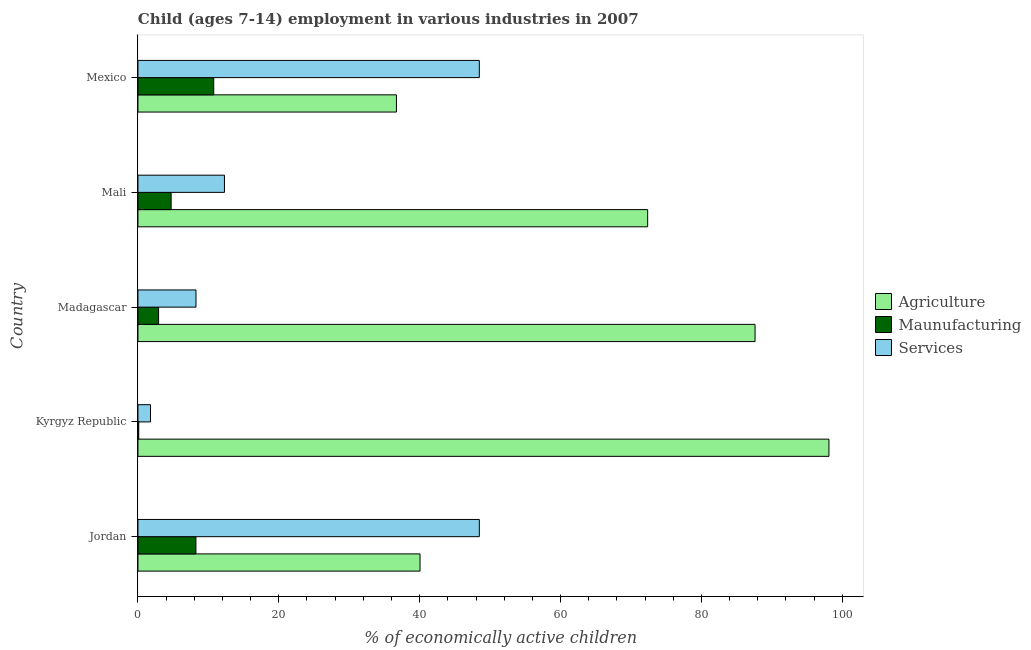How many groups of bars are there?
Your answer should be very brief. 5. Are the number of bars on each tick of the Y-axis equal?
Give a very brief answer. Yes. How many bars are there on the 2nd tick from the top?
Provide a succinct answer. 3. What is the label of the 3rd group of bars from the top?
Offer a very short reply. Madagascar. In how many cases, is the number of bars for a given country not equal to the number of legend labels?
Offer a terse response. 0. What is the percentage of economically active children in manufacturing in Mexico?
Provide a short and direct response. 10.76. Across all countries, what is the maximum percentage of economically active children in agriculture?
Your response must be concise. 98.11. Across all countries, what is the minimum percentage of economically active children in manufacturing?
Give a very brief answer. 0.11. In which country was the percentage of economically active children in manufacturing maximum?
Provide a succinct answer. Mexico. In which country was the percentage of economically active children in services minimum?
Your answer should be compact. Kyrgyz Republic. What is the total percentage of economically active children in manufacturing in the graph?
Give a very brief answer. 26.74. What is the difference between the percentage of economically active children in services in Mali and that in Mexico?
Ensure brevity in your answer.  -36.19. What is the difference between the percentage of economically active children in manufacturing in Mali and the percentage of economically active children in agriculture in Jordan?
Ensure brevity in your answer.  -35.34. What is the average percentage of economically active children in agriculture per country?
Offer a terse response. 66.97. What is the difference between the percentage of economically active children in services and percentage of economically active children in manufacturing in Madagascar?
Give a very brief answer. 5.31. What is the ratio of the percentage of economically active children in services in Madagascar to that in Mali?
Provide a succinct answer. 0.67. Is the difference between the percentage of economically active children in services in Kyrgyz Republic and Mali greater than the difference between the percentage of economically active children in manufacturing in Kyrgyz Republic and Mali?
Your response must be concise. No. What is the difference between the highest and the second highest percentage of economically active children in services?
Your response must be concise. 0. What is the difference between the highest and the lowest percentage of economically active children in services?
Your response must be concise. 46.69. Is the sum of the percentage of economically active children in services in Madagascar and Mali greater than the maximum percentage of economically active children in agriculture across all countries?
Keep it short and to the point. No. What does the 2nd bar from the top in Madagascar represents?
Make the answer very short. Maunufacturing. What does the 3rd bar from the bottom in Jordan represents?
Your response must be concise. Services. How many bars are there?
Offer a terse response. 15. Are all the bars in the graph horizontal?
Make the answer very short. Yes. How many countries are there in the graph?
Provide a short and direct response. 5. Does the graph contain any zero values?
Your answer should be very brief. No. Does the graph contain grids?
Ensure brevity in your answer.  No. What is the title of the graph?
Your answer should be compact. Child (ages 7-14) employment in various industries in 2007. Does "Total employers" appear as one of the legend labels in the graph?
Give a very brief answer. No. What is the label or title of the X-axis?
Offer a terse response. % of economically active children. What is the % of economically active children in Agriculture in Jordan?
Your answer should be compact. 40.05. What is the % of economically active children in Maunufacturing in Jordan?
Ensure brevity in your answer.  8.23. What is the % of economically active children of Services in Jordan?
Offer a terse response. 48.47. What is the % of economically active children of Agriculture in Kyrgyz Republic?
Make the answer very short. 98.11. What is the % of economically active children in Maunufacturing in Kyrgyz Republic?
Offer a very short reply. 0.11. What is the % of economically active children in Services in Kyrgyz Republic?
Provide a succinct answer. 1.78. What is the % of economically active children in Agriculture in Madagascar?
Give a very brief answer. 87.62. What is the % of economically active children of Maunufacturing in Madagascar?
Offer a very short reply. 2.93. What is the % of economically active children in Services in Madagascar?
Ensure brevity in your answer.  8.24. What is the % of economically active children of Agriculture in Mali?
Keep it short and to the point. 72.37. What is the % of economically active children of Maunufacturing in Mali?
Offer a terse response. 4.71. What is the % of economically active children in Services in Mali?
Your answer should be compact. 12.28. What is the % of economically active children of Agriculture in Mexico?
Your answer should be compact. 36.7. What is the % of economically active children in Maunufacturing in Mexico?
Make the answer very short. 10.76. What is the % of economically active children of Services in Mexico?
Your response must be concise. 48.47. Across all countries, what is the maximum % of economically active children of Agriculture?
Your answer should be very brief. 98.11. Across all countries, what is the maximum % of economically active children in Maunufacturing?
Make the answer very short. 10.76. Across all countries, what is the maximum % of economically active children of Services?
Give a very brief answer. 48.47. Across all countries, what is the minimum % of economically active children in Agriculture?
Make the answer very short. 36.7. Across all countries, what is the minimum % of economically active children in Maunufacturing?
Keep it short and to the point. 0.11. Across all countries, what is the minimum % of economically active children in Services?
Offer a very short reply. 1.78. What is the total % of economically active children in Agriculture in the graph?
Keep it short and to the point. 334.85. What is the total % of economically active children in Maunufacturing in the graph?
Provide a succinct answer. 26.74. What is the total % of economically active children of Services in the graph?
Your response must be concise. 119.24. What is the difference between the % of economically active children of Agriculture in Jordan and that in Kyrgyz Republic?
Provide a succinct answer. -58.06. What is the difference between the % of economically active children of Maunufacturing in Jordan and that in Kyrgyz Republic?
Your answer should be very brief. 8.12. What is the difference between the % of economically active children of Services in Jordan and that in Kyrgyz Republic?
Make the answer very short. 46.69. What is the difference between the % of economically active children of Agriculture in Jordan and that in Madagascar?
Your answer should be compact. -47.57. What is the difference between the % of economically active children of Services in Jordan and that in Madagascar?
Your answer should be compact. 40.23. What is the difference between the % of economically active children in Agriculture in Jordan and that in Mali?
Ensure brevity in your answer.  -32.32. What is the difference between the % of economically active children of Maunufacturing in Jordan and that in Mali?
Make the answer very short. 3.52. What is the difference between the % of economically active children of Services in Jordan and that in Mali?
Provide a succinct answer. 36.19. What is the difference between the % of economically active children of Agriculture in Jordan and that in Mexico?
Offer a very short reply. 3.35. What is the difference between the % of economically active children of Maunufacturing in Jordan and that in Mexico?
Offer a terse response. -2.53. What is the difference between the % of economically active children in Services in Jordan and that in Mexico?
Your response must be concise. 0. What is the difference between the % of economically active children of Agriculture in Kyrgyz Republic and that in Madagascar?
Ensure brevity in your answer.  10.49. What is the difference between the % of economically active children of Maunufacturing in Kyrgyz Republic and that in Madagascar?
Ensure brevity in your answer.  -2.82. What is the difference between the % of economically active children of Services in Kyrgyz Republic and that in Madagascar?
Your answer should be compact. -6.46. What is the difference between the % of economically active children in Agriculture in Kyrgyz Republic and that in Mali?
Offer a very short reply. 25.74. What is the difference between the % of economically active children in Maunufacturing in Kyrgyz Republic and that in Mali?
Keep it short and to the point. -4.6. What is the difference between the % of economically active children in Agriculture in Kyrgyz Republic and that in Mexico?
Keep it short and to the point. 61.41. What is the difference between the % of economically active children of Maunufacturing in Kyrgyz Republic and that in Mexico?
Your answer should be compact. -10.65. What is the difference between the % of economically active children of Services in Kyrgyz Republic and that in Mexico?
Provide a short and direct response. -46.69. What is the difference between the % of economically active children of Agriculture in Madagascar and that in Mali?
Keep it short and to the point. 15.25. What is the difference between the % of economically active children in Maunufacturing in Madagascar and that in Mali?
Offer a terse response. -1.78. What is the difference between the % of economically active children in Services in Madagascar and that in Mali?
Provide a succinct answer. -4.04. What is the difference between the % of economically active children in Agriculture in Madagascar and that in Mexico?
Provide a short and direct response. 50.92. What is the difference between the % of economically active children in Maunufacturing in Madagascar and that in Mexico?
Make the answer very short. -7.83. What is the difference between the % of economically active children in Services in Madagascar and that in Mexico?
Keep it short and to the point. -40.23. What is the difference between the % of economically active children in Agriculture in Mali and that in Mexico?
Ensure brevity in your answer.  35.67. What is the difference between the % of economically active children in Maunufacturing in Mali and that in Mexico?
Provide a short and direct response. -6.05. What is the difference between the % of economically active children of Services in Mali and that in Mexico?
Your answer should be very brief. -36.19. What is the difference between the % of economically active children of Agriculture in Jordan and the % of economically active children of Maunufacturing in Kyrgyz Republic?
Your response must be concise. 39.94. What is the difference between the % of economically active children in Agriculture in Jordan and the % of economically active children in Services in Kyrgyz Republic?
Keep it short and to the point. 38.27. What is the difference between the % of economically active children of Maunufacturing in Jordan and the % of economically active children of Services in Kyrgyz Republic?
Give a very brief answer. 6.45. What is the difference between the % of economically active children in Agriculture in Jordan and the % of economically active children in Maunufacturing in Madagascar?
Your response must be concise. 37.12. What is the difference between the % of economically active children of Agriculture in Jordan and the % of economically active children of Services in Madagascar?
Make the answer very short. 31.81. What is the difference between the % of economically active children in Maunufacturing in Jordan and the % of economically active children in Services in Madagascar?
Your answer should be compact. -0.01. What is the difference between the % of economically active children of Agriculture in Jordan and the % of economically active children of Maunufacturing in Mali?
Provide a succinct answer. 35.34. What is the difference between the % of economically active children of Agriculture in Jordan and the % of economically active children of Services in Mali?
Provide a short and direct response. 27.77. What is the difference between the % of economically active children of Maunufacturing in Jordan and the % of economically active children of Services in Mali?
Offer a very short reply. -4.05. What is the difference between the % of economically active children in Agriculture in Jordan and the % of economically active children in Maunufacturing in Mexico?
Your answer should be compact. 29.29. What is the difference between the % of economically active children of Agriculture in Jordan and the % of economically active children of Services in Mexico?
Provide a succinct answer. -8.42. What is the difference between the % of economically active children of Maunufacturing in Jordan and the % of economically active children of Services in Mexico?
Make the answer very short. -40.24. What is the difference between the % of economically active children of Agriculture in Kyrgyz Republic and the % of economically active children of Maunufacturing in Madagascar?
Offer a terse response. 95.18. What is the difference between the % of economically active children of Agriculture in Kyrgyz Republic and the % of economically active children of Services in Madagascar?
Offer a terse response. 89.87. What is the difference between the % of economically active children in Maunufacturing in Kyrgyz Republic and the % of economically active children in Services in Madagascar?
Offer a terse response. -8.13. What is the difference between the % of economically active children of Agriculture in Kyrgyz Republic and the % of economically active children of Maunufacturing in Mali?
Offer a very short reply. 93.4. What is the difference between the % of economically active children in Agriculture in Kyrgyz Republic and the % of economically active children in Services in Mali?
Offer a terse response. 85.83. What is the difference between the % of economically active children of Maunufacturing in Kyrgyz Republic and the % of economically active children of Services in Mali?
Ensure brevity in your answer.  -12.17. What is the difference between the % of economically active children in Agriculture in Kyrgyz Republic and the % of economically active children in Maunufacturing in Mexico?
Keep it short and to the point. 87.35. What is the difference between the % of economically active children of Agriculture in Kyrgyz Republic and the % of economically active children of Services in Mexico?
Keep it short and to the point. 49.64. What is the difference between the % of economically active children of Maunufacturing in Kyrgyz Republic and the % of economically active children of Services in Mexico?
Make the answer very short. -48.36. What is the difference between the % of economically active children of Agriculture in Madagascar and the % of economically active children of Maunufacturing in Mali?
Keep it short and to the point. 82.91. What is the difference between the % of economically active children in Agriculture in Madagascar and the % of economically active children in Services in Mali?
Make the answer very short. 75.34. What is the difference between the % of economically active children in Maunufacturing in Madagascar and the % of economically active children in Services in Mali?
Keep it short and to the point. -9.35. What is the difference between the % of economically active children in Agriculture in Madagascar and the % of economically active children in Maunufacturing in Mexico?
Your answer should be very brief. 76.86. What is the difference between the % of economically active children in Agriculture in Madagascar and the % of economically active children in Services in Mexico?
Provide a succinct answer. 39.15. What is the difference between the % of economically active children of Maunufacturing in Madagascar and the % of economically active children of Services in Mexico?
Your answer should be very brief. -45.54. What is the difference between the % of economically active children of Agriculture in Mali and the % of economically active children of Maunufacturing in Mexico?
Provide a succinct answer. 61.61. What is the difference between the % of economically active children of Agriculture in Mali and the % of economically active children of Services in Mexico?
Keep it short and to the point. 23.9. What is the difference between the % of economically active children in Maunufacturing in Mali and the % of economically active children in Services in Mexico?
Your response must be concise. -43.76. What is the average % of economically active children in Agriculture per country?
Ensure brevity in your answer.  66.97. What is the average % of economically active children of Maunufacturing per country?
Your response must be concise. 5.35. What is the average % of economically active children of Services per country?
Ensure brevity in your answer.  23.85. What is the difference between the % of economically active children of Agriculture and % of economically active children of Maunufacturing in Jordan?
Make the answer very short. 31.82. What is the difference between the % of economically active children in Agriculture and % of economically active children in Services in Jordan?
Offer a very short reply. -8.42. What is the difference between the % of economically active children in Maunufacturing and % of economically active children in Services in Jordan?
Your answer should be very brief. -40.24. What is the difference between the % of economically active children of Agriculture and % of economically active children of Services in Kyrgyz Republic?
Provide a short and direct response. 96.33. What is the difference between the % of economically active children of Maunufacturing and % of economically active children of Services in Kyrgyz Republic?
Keep it short and to the point. -1.67. What is the difference between the % of economically active children in Agriculture and % of economically active children in Maunufacturing in Madagascar?
Your answer should be very brief. 84.69. What is the difference between the % of economically active children of Agriculture and % of economically active children of Services in Madagascar?
Keep it short and to the point. 79.38. What is the difference between the % of economically active children in Maunufacturing and % of economically active children in Services in Madagascar?
Your response must be concise. -5.31. What is the difference between the % of economically active children of Agriculture and % of economically active children of Maunufacturing in Mali?
Offer a very short reply. 67.66. What is the difference between the % of economically active children in Agriculture and % of economically active children in Services in Mali?
Your answer should be very brief. 60.09. What is the difference between the % of economically active children of Maunufacturing and % of economically active children of Services in Mali?
Your answer should be very brief. -7.57. What is the difference between the % of economically active children in Agriculture and % of economically active children in Maunufacturing in Mexico?
Ensure brevity in your answer.  25.94. What is the difference between the % of economically active children in Agriculture and % of economically active children in Services in Mexico?
Provide a short and direct response. -11.77. What is the difference between the % of economically active children of Maunufacturing and % of economically active children of Services in Mexico?
Provide a short and direct response. -37.71. What is the ratio of the % of economically active children in Agriculture in Jordan to that in Kyrgyz Republic?
Your response must be concise. 0.41. What is the ratio of the % of economically active children in Maunufacturing in Jordan to that in Kyrgyz Republic?
Keep it short and to the point. 74.82. What is the ratio of the % of economically active children of Services in Jordan to that in Kyrgyz Republic?
Provide a succinct answer. 27.23. What is the ratio of the % of economically active children in Agriculture in Jordan to that in Madagascar?
Give a very brief answer. 0.46. What is the ratio of the % of economically active children in Maunufacturing in Jordan to that in Madagascar?
Offer a very short reply. 2.81. What is the ratio of the % of economically active children of Services in Jordan to that in Madagascar?
Offer a very short reply. 5.88. What is the ratio of the % of economically active children of Agriculture in Jordan to that in Mali?
Provide a succinct answer. 0.55. What is the ratio of the % of economically active children of Maunufacturing in Jordan to that in Mali?
Give a very brief answer. 1.75. What is the ratio of the % of economically active children of Services in Jordan to that in Mali?
Provide a short and direct response. 3.95. What is the ratio of the % of economically active children of Agriculture in Jordan to that in Mexico?
Provide a succinct answer. 1.09. What is the ratio of the % of economically active children of Maunufacturing in Jordan to that in Mexico?
Your answer should be very brief. 0.76. What is the ratio of the % of economically active children of Services in Jordan to that in Mexico?
Offer a terse response. 1. What is the ratio of the % of economically active children of Agriculture in Kyrgyz Republic to that in Madagascar?
Keep it short and to the point. 1.12. What is the ratio of the % of economically active children of Maunufacturing in Kyrgyz Republic to that in Madagascar?
Offer a terse response. 0.04. What is the ratio of the % of economically active children in Services in Kyrgyz Republic to that in Madagascar?
Provide a short and direct response. 0.22. What is the ratio of the % of economically active children of Agriculture in Kyrgyz Republic to that in Mali?
Your response must be concise. 1.36. What is the ratio of the % of economically active children in Maunufacturing in Kyrgyz Republic to that in Mali?
Make the answer very short. 0.02. What is the ratio of the % of economically active children of Services in Kyrgyz Republic to that in Mali?
Your response must be concise. 0.14. What is the ratio of the % of economically active children in Agriculture in Kyrgyz Republic to that in Mexico?
Offer a terse response. 2.67. What is the ratio of the % of economically active children of Maunufacturing in Kyrgyz Republic to that in Mexico?
Your answer should be very brief. 0.01. What is the ratio of the % of economically active children of Services in Kyrgyz Republic to that in Mexico?
Give a very brief answer. 0.04. What is the ratio of the % of economically active children in Agriculture in Madagascar to that in Mali?
Your answer should be compact. 1.21. What is the ratio of the % of economically active children in Maunufacturing in Madagascar to that in Mali?
Provide a succinct answer. 0.62. What is the ratio of the % of economically active children in Services in Madagascar to that in Mali?
Your answer should be compact. 0.67. What is the ratio of the % of economically active children of Agriculture in Madagascar to that in Mexico?
Ensure brevity in your answer.  2.39. What is the ratio of the % of economically active children in Maunufacturing in Madagascar to that in Mexico?
Offer a very short reply. 0.27. What is the ratio of the % of economically active children of Services in Madagascar to that in Mexico?
Provide a short and direct response. 0.17. What is the ratio of the % of economically active children in Agriculture in Mali to that in Mexico?
Give a very brief answer. 1.97. What is the ratio of the % of economically active children in Maunufacturing in Mali to that in Mexico?
Provide a succinct answer. 0.44. What is the ratio of the % of economically active children in Services in Mali to that in Mexico?
Provide a short and direct response. 0.25. What is the difference between the highest and the second highest % of economically active children in Agriculture?
Your answer should be very brief. 10.49. What is the difference between the highest and the second highest % of economically active children in Maunufacturing?
Your answer should be compact. 2.53. What is the difference between the highest and the lowest % of economically active children of Agriculture?
Make the answer very short. 61.41. What is the difference between the highest and the lowest % of economically active children of Maunufacturing?
Offer a very short reply. 10.65. What is the difference between the highest and the lowest % of economically active children of Services?
Provide a succinct answer. 46.69. 